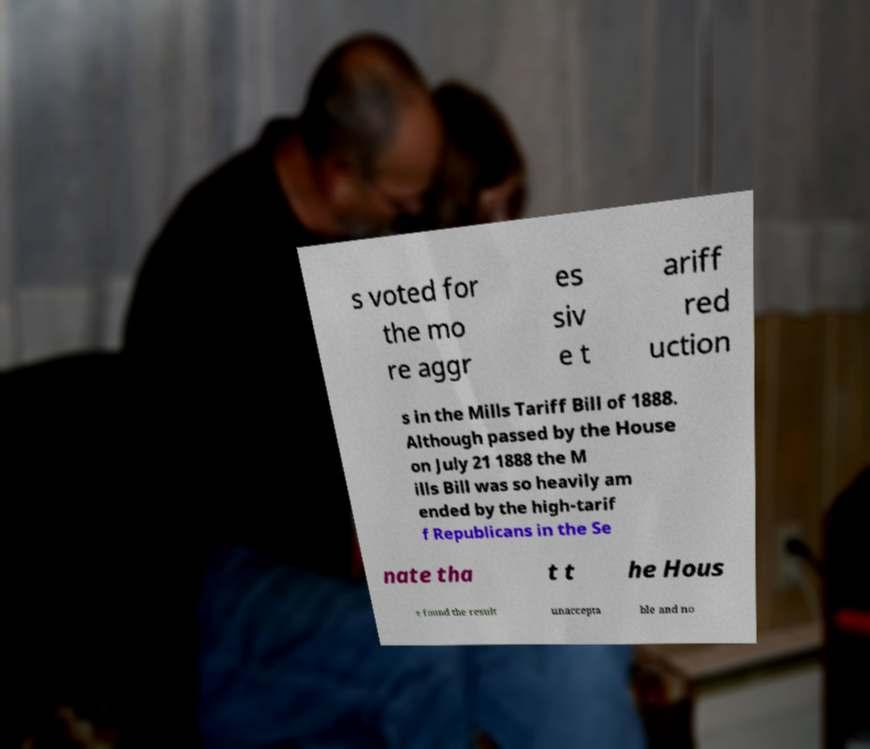For documentation purposes, I need the text within this image transcribed. Could you provide that? s voted for the mo re aggr es siv e t ariff red uction s in the Mills Tariff Bill of 1888. Although passed by the House on July 21 1888 the M ills Bill was so heavily am ended by the high-tarif f Republicans in the Se nate tha t t he Hous e found the result unaccepta ble and no 